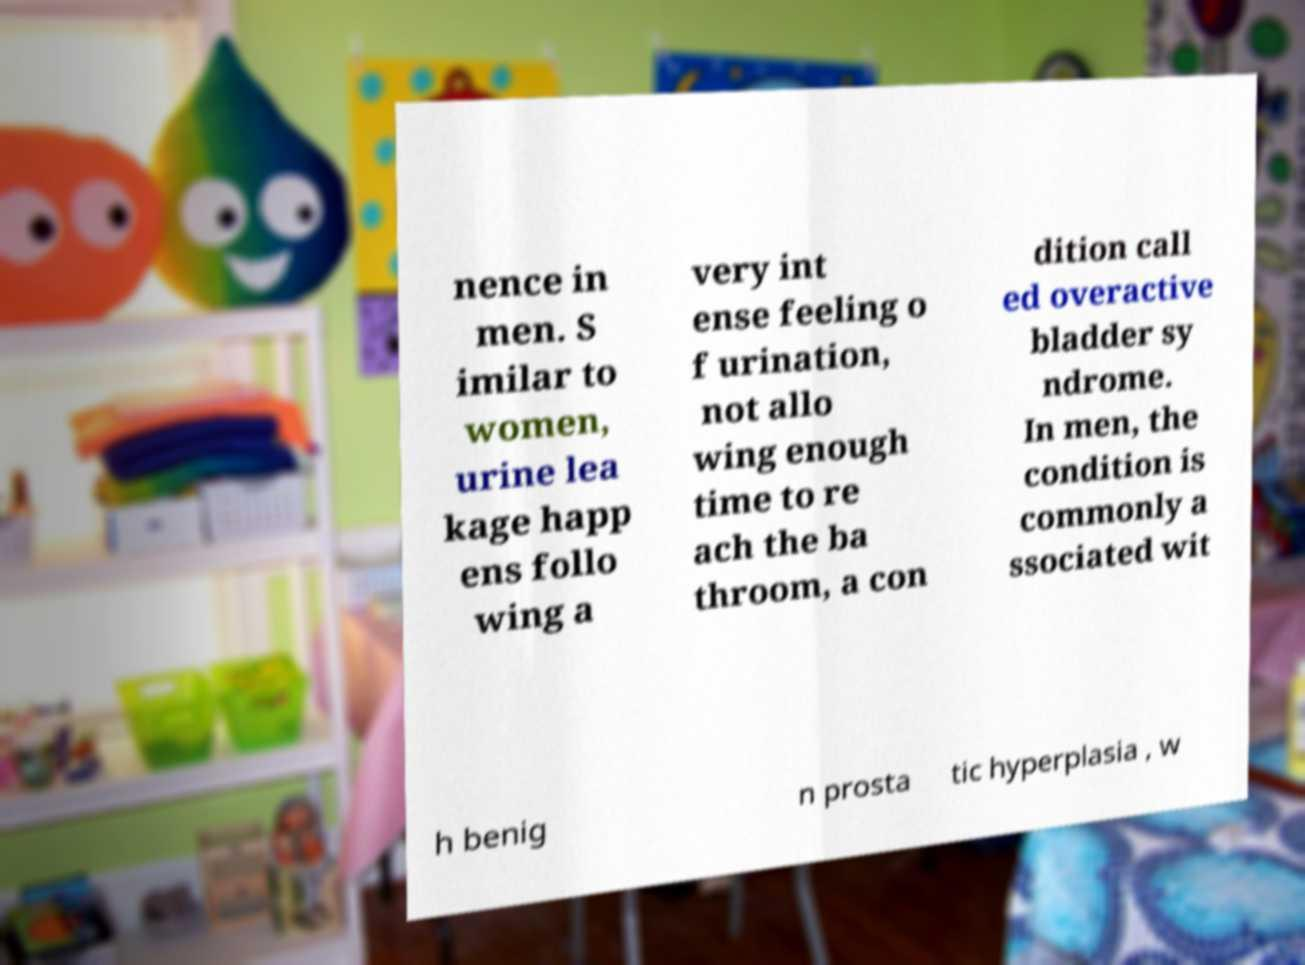Could you extract and type out the text from this image? nence in men. S imilar to women, urine lea kage happ ens follo wing a very int ense feeling o f urination, not allo wing enough time to re ach the ba throom, a con dition call ed overactive bladder sy ndrome. In men, the condition is commonly a ssociated wit h benig n prosta tic hyperplasia , w 